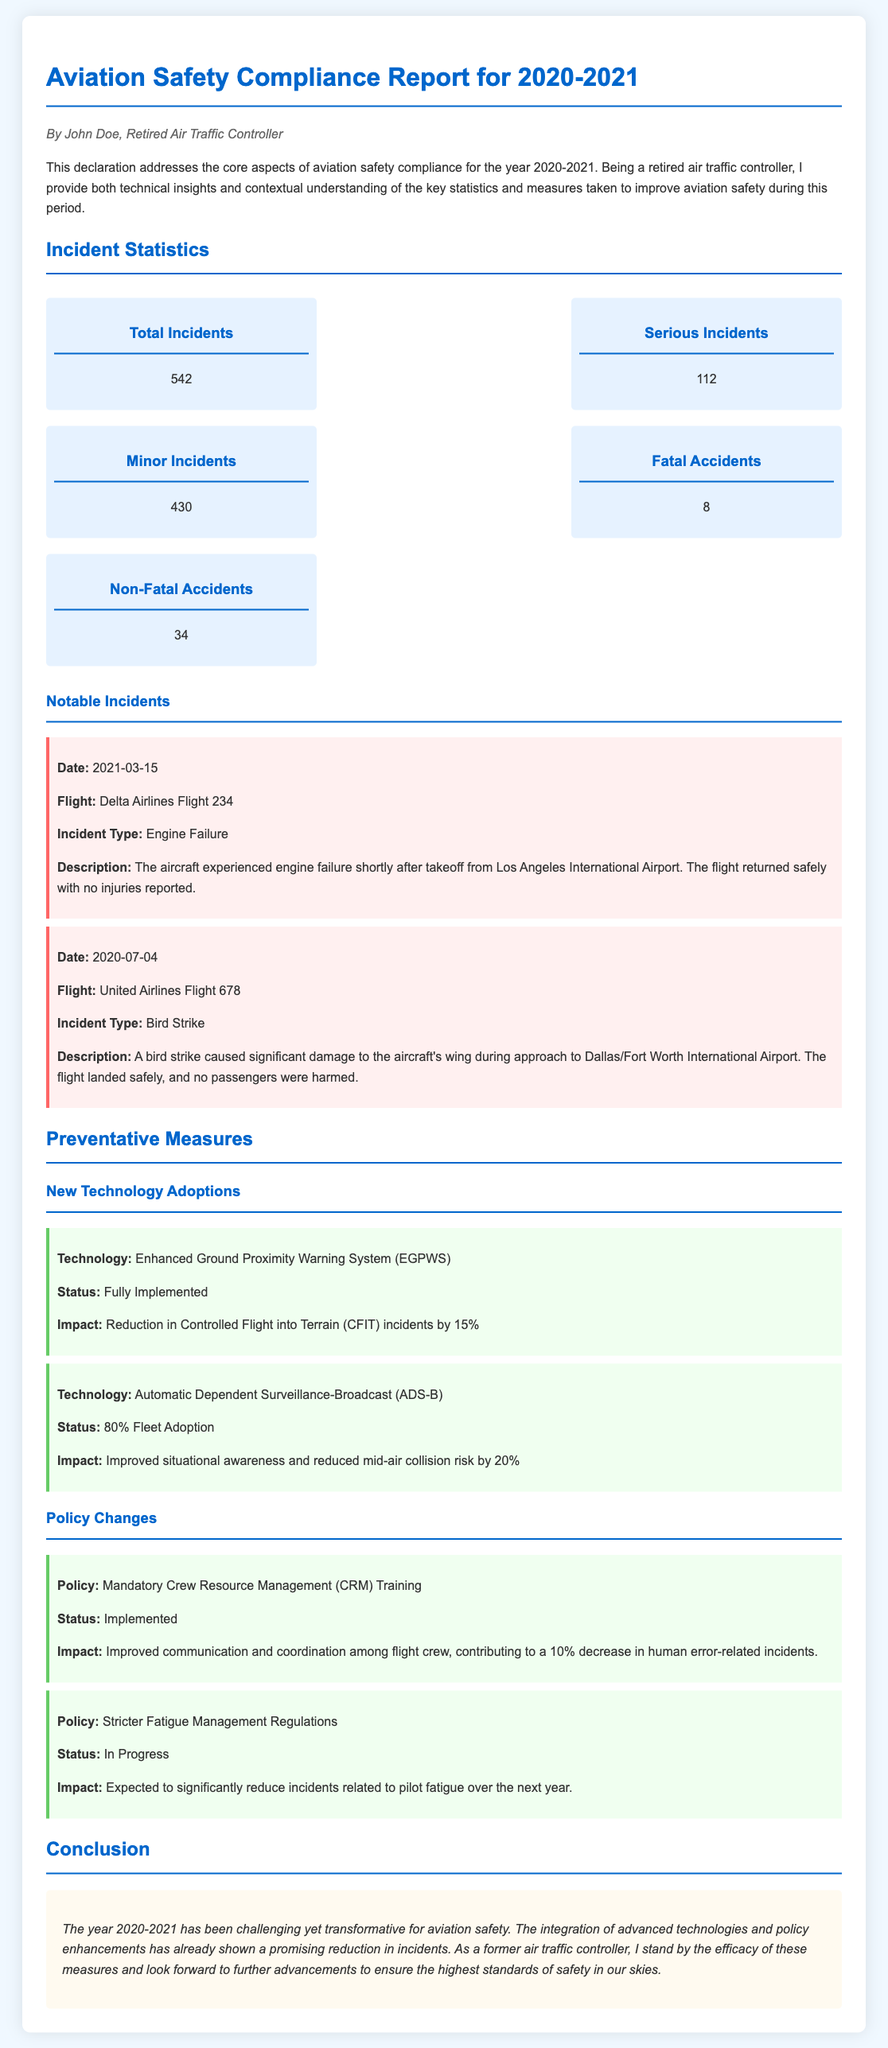What is the total number of incidents? The total number of incidents is explicitly stated in the statistics section of the document.
Answer: 542 How many serious incidents were reported? The number of serious incidents is specifically mentioned in the incident statistics.
Answer: 112 What percentage reduction in CFIT incidents was achieved? The impact of the Enhanced Ground Proximity Warning System mentions a specific percentage reduction.
Answer: 15% What is the incident type of Delta Airlines Flight 234? The incident type for Delta Airlines Flight 234 is listed under notable incidents.
Answer: Engine Failure What is the status of the stricter fatigue management regulations? The status of the policy regarding fatigue management is mentioned in the preventative measures section.
Answer: In Progress How many non-fatal accidents occurred? The number of non-fatal accidents is found in the overall incident statistics.
Answer: 34 What technology has an 80% fleet adoption rate? The technology with this specific adoption rate is detailed in the new technology adoptions section.
Answer: Automatic Dependent Surveillance-Broadcast (ADS-B) What role does Crew Resource Management training play in aviation safety? The impact of this training on incident reduction is summarized in the document.
Answer: Improved communication How many fatal accidents were reported? The document specifies the total number of fatal accidents within the incident statistics.
Answer: 8 